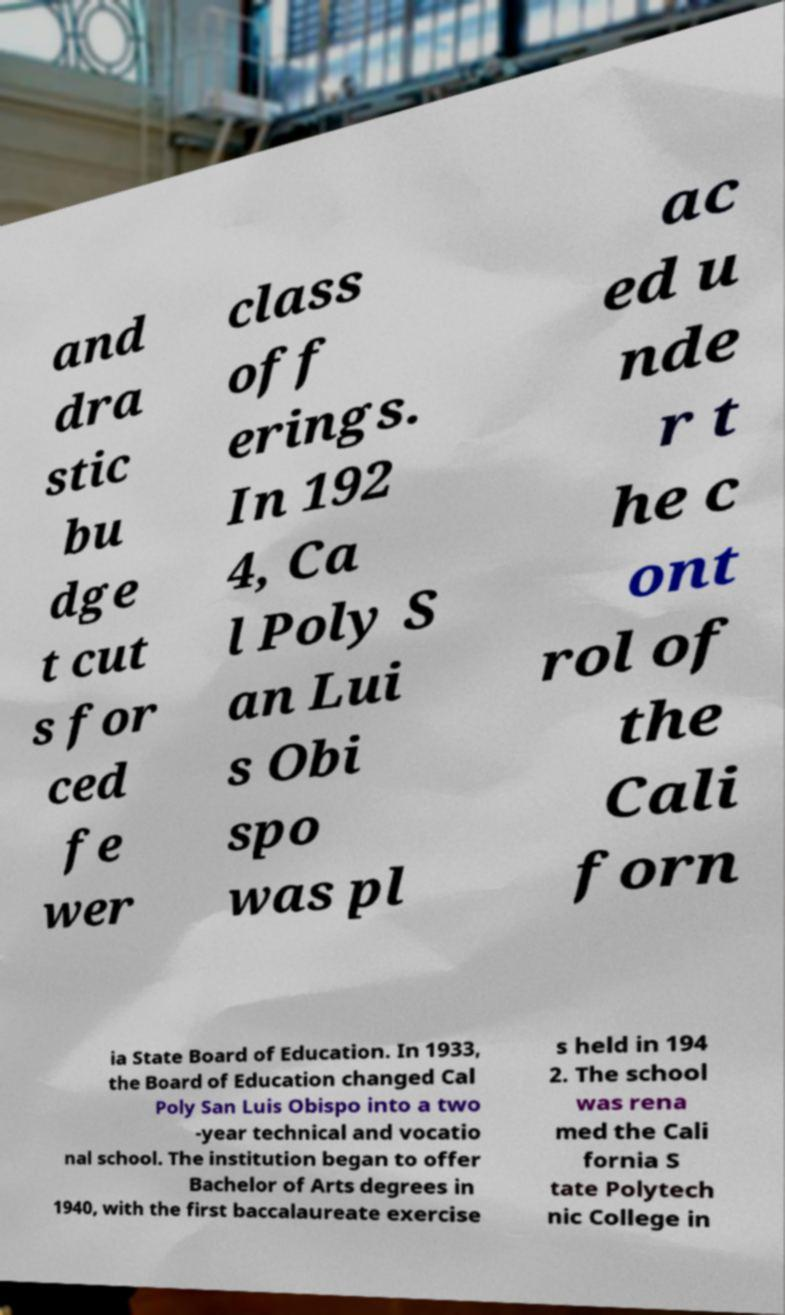I need the written content from this picture converted into text. Can you do that? and dra stic bu dge t cut s for ced fe wer class off erings. In 192 4, Ca l Poly S an Lui s Obi spo was pl ac ed u nde r t he c ont rol of the Cali forn ia State Board of Education. In 1933, the Board of Education changed Cal Poly San Luis Obispo into a two -year technical and vocatio nal school. The institution began to offer Bachelor of Arts degrees in 1940, with the first baccalaureate exercise s held in 194 2. The school was rena med the Cali fornia S tate Polytech nic College in 